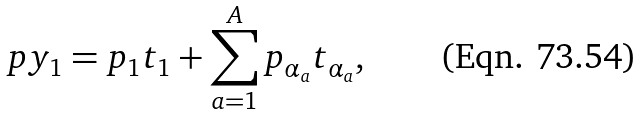Convert formula to latex. <formula><loc_0><loc_0><loc_500><loc_500>p y _ { 1 } = p _ { 1 } t _ { 1 } + \sum _ { a = 1 } ^ { A } p _ { \alpha _ { a } } t _ { \alpha _ { a } } ,</formula> 